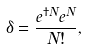<formula> <loc_0><loc_0><loc_500><loc_500>\delta = \frac { e ^ { \dagger N } e ^ { N } } { N ! } ,</formula> 